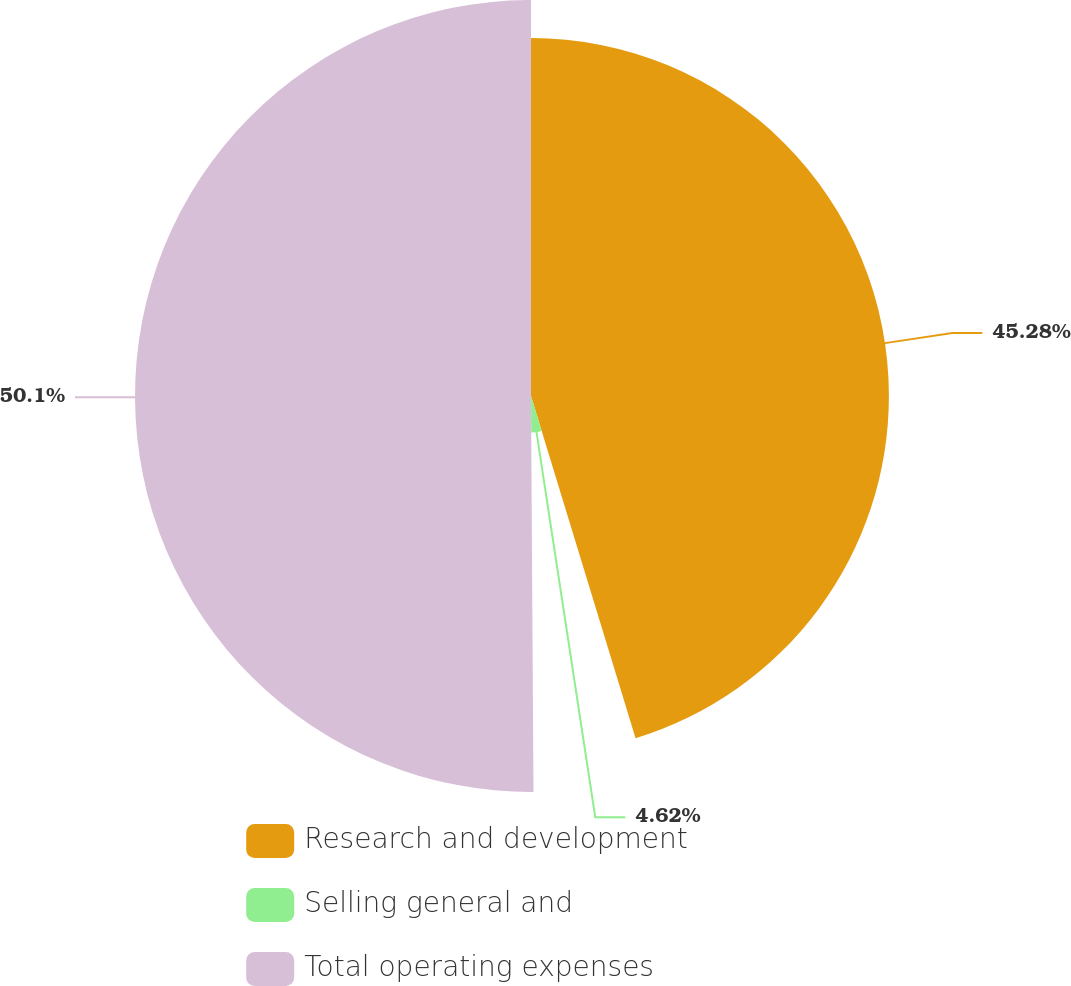Convert chart to OTSL. <chart><loc_0><loc_0><loc_500><loc_500><pie_chart><fcel>Research and development<fcel>Selling general and<fcel>Total operating expenses<nl><fcel>45.28%<fcel>4.62%<fcel>50.1%<nl></chart> 